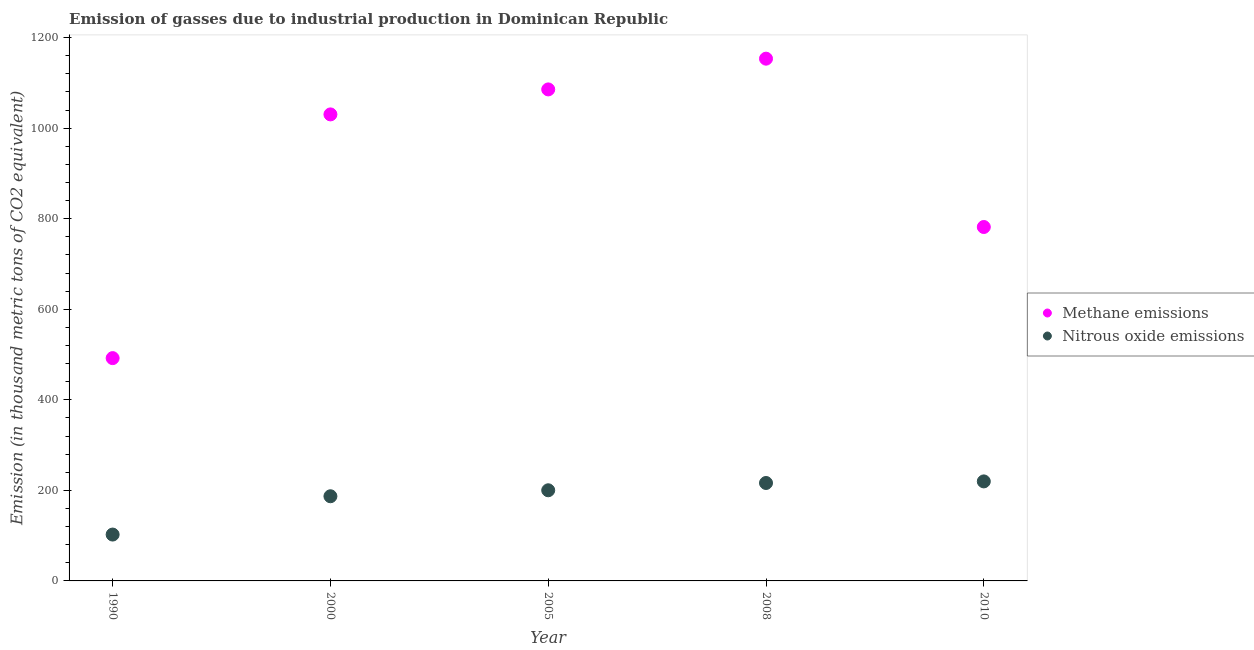Is the number of dotlines equal to the number of legend labels?
Make the answer very short. Yes. What is the amount of methane emissions in 1990?
Keep it short and to the point. 492.1. Across all years, what is the maximum amount of nitrous oxide emissions?
Make the answer very short. 219.8. Across all years, what is the minimum amount of methane emissions?
Ensure brevity in your answer.  492.1. What is the total amount of nitrous oxide emissions in the graph?
Your response must be concise. 925.7. What is the difference between the amount of nitrous oxide emissions in 1990 and that in 2005?
Your answer should be very brief. -97.8. What is the difference between the amount of methane emissions in 1990 and the amount of nitrous oxide emissions in 2008?
Offer a terse response. 275.8. What is the average amount of methane emissions per year?
Ensure brevity in your answer.  908.66. In the year 2008, what is the difference between the amount of methane emissions and amount of nitrous oxide emissions?
Provide a succinct answer. 937.2. What is the ratio of the amount of methane emissions in 2008 to that in 2010?
Your response must be concise. 1.48. Is the amount of nitrous oxide emissions in 2000 less than that in 2008?
Give a very brief answer. Yes. What is the difference between the highest and the lowest amount of methane emissions?
Keep it short and to the point. 661.4. How many dotlines are there?
Give a very brief answer. 2. How many years are there in the graph?
Offer a very short reply. 5. What is the difference between two consecutive major ticks on the Y-axis?
Provide a succinct answer. 200. Are the values on the major ticks of Y-axis written in scientific E-notation?
Provide a succinct answer. No. Does the graph contain grids?
Your answer should be very brief. No. Where does the legend appear in the graph?
Offer a terse response. Center right. How are the legend labels stacked?
Your answer should be compact. Vertical. What is the title of the graph?
Your response must be concise. Emission of gasses due to industrial production in Dominican Republic. What is the label or title of the Y-axis?
Your answer should be compact. Emission (in thousand metric tons of CO2 equivalent). What is the Emission (in thousand metric tons of CO2 equivalent) in Methane emissions in 1990?
Make the answer very short. 492.1. What is the Emission (in thousand metric tons of CO2 equivalent) in Nitrous oxide emissions in 1990?
Your answer should be compact. 102.4. What is the Emission (in thousand metric tons of CO2 equivalent) of Methane emissions in 2000?
Provide a short and direct response. 1030.4. What is the Emission (in thousand metric tons of CO2 equivalent) in Nitrous oxide emissions in 2000?
Provide a short and direct response. 187. What is the Emission (in thousand metric tons of CO2 equivalent) of Methane emissions in 2005?
Offer a terse response. 1085.6. What is the Emission (in thousand metric tons of CO2 equivalent) of Nitrous oxide emissions in 2005?
Make the answer very short. 200.2. What is the Emission (in thousand metric tons of CO2 equivalent) of Methane emissions in 2008?
Your answer should be very brief. 1153.5. What is the Emission (in thousand metric tons of CO2 equivalent) of Nitrous oxide emissions in 2008?
Offer a very short reply. 216.3. What is the Emission (in thousand metric tons of CO2 equivalent) in Methane emissions in 2010?
Give a very brief answer. 781.7. What is the Emission (in thousand metric tons of CO2 equivalent) of Nitrous oxide emissions in 2010?
Keep it short and to the point. 219.8. Across all years, what is the maximum Emission (in thousand metric tons of CO2 equivalent) of Methane emissions?
Ensure brevity in your answer.  1153.5. Across all years, what is the maximum Emission (in thousand metric tons of CO2 equivalent) of Nitrous oxide emissions?
Provide a succinct answer. 219.8. Across all years, what is the minimum Emission (in thousand metric tons of CO2 equivalent) of Methane emissions?
Offer a very short reply. 492.1. Across all years, what is the minimum Emission (in thousand metric tons of CO2 equivalent) in Nitrous oxide emissions?
Offer a very short reply. 102.4. What is the total Emission (in thousand metric tons of CO2 equivalent) in Methane emissions in the graph?
Ensure brevity in your answer.  4543.3. What is the total Emission (in thousand metric tons of CO2 equivalent) of Nitrous oxide emissions in the graph?
Ensure brevity in your answer.  925.7. What is the difference between the Emission (in thousand metric tons of CO2 equivalent) of Methane emissions in 1990 and that in 2000?
Provide a short and direct response. -538.3. What is the difference between the Emission (in thousand metric tons of CO2 equivalent) of Nitrous oxide emissions in 1990 and that in 2000?
Provide a short and direct response. -84.6. What is the difference between the Emission (in thousand metric tons of CO2 equivalent) of Methane emissions in 1990 and that in 2005?
Offer a very short reply. -593.5. What is the difference between the Emission (in thousand metric tons of CO2 equivalent) in Nitrous oxide emissions in 1990 and that in 2005?
Make the answer very short. -97.8. What is the difference between the Emission (in thousand metric tons of CO2 equivalent) of Methane emissions in 1990 and that in 2008?
Give a very brief answer. -661.4. What is the difference between the Emission (in thousand metric tons of CO2 equivalent) of Nitrous oxide emissions in 1990 and that in 2008?
Make the answer very short. -113.9. What is the difference between the Emission (in thousand metric tons of CO2 equivalent) of Methane emissions in 1990 and that in 2010?
Provide a succinct answer. -289.6. What is the difference between the Emission (in thousand metric tons of CO2 equivalent) of Nitrous oxide emissions in 1990 and that in 2010?
Provide a succinct answer. -117.4. What is the difference between the Emission (in thousand metric tons of CO2 equivalent) in Methane emissions in 2000 and that in 2005?
Provide a succinct answer. -55.2. What is the difference between the Emission (in thousand metric tons of CO2 equivalent) of Methane emissions in 2000 and that in 2008?
Provide a succinct answer. -123.1. What is the difference between the Emission (in thousand metric tons of CO2 equivalent) in Nitrous oxide emissions in 2000 and that in 2008?
Give a very brief answer. -29.3. What is the difference between the Emission (in thousand metric tons of CO2 equivalent) of Methane emissions in 2000 and that in 2010?
Your response must be concise. 248.7. What is the difference between the Emission (in thousand metric tons of CO2 equivalent) in Nitrous oxide emissions in 2000 and that in 2010?
Offer a terse response. -32.8. What is the difference between the Emission (in thousand metric tons of CO2 equivalent) of Methane emissions in 2005 and that in 2008?
Keep it short and to the point. -67.9. What is the difference between the Emission (in thousand metric tons of CO2 equivalent) in Nitrous oxide emissions in 2005 and that in 2008?
Keep it short and to the point. -16.1. What is the difference between the Emission (in thousand metric tons of CO2 equivalent) of Methane emissions in 2005 and that in 2010?
Make the answer very short. 303.9. What is the difference between the Emission (in thousand metric tons of CO2 equivalent) of Nitrous oxide emissions in 2005 and that in 2010?
Give a very brief answer. -19.6. What is the difference between the Emission (in thousand metric tons of CO2 equivalent) of Methane emissions in 2008 and that in 2010?
Offer a terse response. 371.8. What is the difference between the Emission (in thousand metric tons of CO2 equivalent) of Methane emissions in 1990 and the Emission (in thousand metric tons of CO2 equivalent) of Nitrous oxide emissions in 2000?
Offer a terse response. 305.1. What is the difference between the Emission (in thousand metric tons of CO2 equivalent) of Methane emissions in 1990 and the Emission (in thousand metric tons of CO2 equivalent) of Nitrous oxide emissions in 2005?
Make the answer very short. 291.9. What is the difference between the Emission (in thousand metric tons of CO2 equivalent) in Methane emissions in 1990 and the Emission (in thousand metric tons of CO2 equivalent) in Nitrous oxide emissions in 2008?
Offer a terse response. 275.8. What is the difference between the Emission (in thousand metric tons of CO2 equivalent) in Methane emissions in 1990 and the Emission (in thousand metric tons of CO2 equivalent) in Nitrous oxide emissions in 2010?
Provide a succinct answer. 272.3. What is the difference between the Emission (in thousand metric tons of CO2 equivalent) in Methane emissions in 2000 and the Emission (in thousand metric tons of CO2 equivalent) in Nitrous oxide emissions in 2005?
Offer a terse response. 830.2. What is the difference between the Emission (in thousand metric tons of CO2 equivalent) of Methane emissions in 2000 and the Emission (in thousand metric tons of CO2 equivalent) of Nitrous oxide emissions in 2008?
Keep it short and to the point. 814.1. What is the difference between the Emission (in thousand metric tons of CO2 equivalent) of Methane emissions in 2000 and the Emission (in thousand metric tons of CO2 equivalent) of Nitrous oxide emissions in 2010?
Provide a succinct answer. 810.6. What is the difference between the Emission (in thousand metric tons of CO2 equivalent) in Methane emissions in 2005 and the Emission (in thousand metric tons of CO2 equivalent) in Nitrous oxide emissions in 2008?
Your answer should be very brief. 869.3. What is the difference between the Emission (in thousand metric tons of CO2 equivalent) of Methane emissions in 2005 and the Emission (in thousand metric tons of CO2 equivalent) of Nitrous oxide emissions in 2010?
Offer a very short reply. 865.8. What is the difference between the Emission (in thousand metric tons of CO2 equivalent) in Methane emissions in 2008 and the Emission (in thousand metric tons of CO2 equivalent) in Nitrous oxide emissions in 2010?
Offer a terse response. 933.7. What is the average Emission (in thousand metric tons of CO2 equivalent) in Methane emissions per year?
Give a very brief answer. 908.66. What is the average Emission (in thousand metric tons of CO2 equivalent) in Nitrous oxide emissions per year?
Keep it short and to the point. 185.14. In the year 1990, what is the difference between the Emission (in thousand metric tons of CO2 equivalent) in Methane emissions and Emission (in thousand metric tons of CO2 equivalent) in Nitrous oxide emissions?
Your answer should be compact. 389.7. In the year 2000, what is the difference between the Emission (in thousand metric tons of CO2 equivalent) of Methane emissions and Emission (in thousand metric tons of CO2 equivalent) of Nitrous oxide emissions?
Ensure brevity in your answer.  843.4. In the year 2005, what is the difference between the Emission (in thousand metric tons of CO2 equivalent) in Methane emissions and Emission (in thousand metric tons of CO2 equivalent) in Nitrous oxide emissions?
Ensure brevity in your answer.  885.4. In the year 2008, what is the difference between the Emission (in thousand metric tons of CO2 equivalent) in Methane emissions and Emission (in thousand metric tons of CO2 equivalent) in Nitrous oxide emissions?
Make the answer very short. 937.2. In the year 2010, what is the difference between the Emission (in thousand metric tons of CO2 equivalent) of Methane emissions and Emission (in thousand metric tons of CO2 equivalent) of Nitrous oxide emissions?
Your response must be concise. 561.9. What is the ratio of the Emission (in thousand metric tons of CO2 equivalent) of Methane emissions in 1990 to that in 2000?
Provide a succinct answer. 0.48. What is the ratio of the Emission (in thousand metric tons of CO2 equivalent) of Nitrous oxide emissions in 1990 to that in 2000?
Give a very brief answer. 0.55. What is the ratio of the Emission (in thousand metric tons of CO2 equivalent) of Methane emissions in 1990 to that in 2005?
Your answer should be compact. 0.45. What is the ratio of the Emission (in thousand metric tons of CO2 equivalent) in Nitrous oxide emissions in 1990 to that in 2005?
Offer a very short reply. 0.51. What is the ratio of the Emission (in thousand metric tons of CO2 equivalent) in Methane emissions in 1990 to that in 2008?
Provide a short and direct response. 0.43. What is the ratio of the Emission (in thousand metric tons of CO2 equivalent) of Nitrous oxide emissions in 1990 to that in 2008?
Your answer should be compact. 0.47. What is the ratio of the Emission (in thousand metric tons of CO2 equivalent) of Methane emissions in 1990 to that in 2010?
Provide a short and direct response. 0.63. What is the ratio of the Emission (in thousand metric tons of CO2 equivalent) in Nitrous oxide emissions in 1990 to that in 2010?
Your answer should be compact. 0.47. What is the ratio of the Emission (in thousand metric tons of CO2 equivalent) of Methane emissions in 2000 to that in 2005?
Provide a short and direct response. 0.95. What is the ratio of the Emission (in thousand metric tons of CO2 equivalent) in Nitrous oxide emissions in 2000 to that in 2005?
Your answer should be compact. 0.93. What is the ratio of the Emission (in thousand metric tons of CO2 equivalent) in Methane emissions in 2000 to that in 2008?
Give a very brief answer. 0.89. What is the ratio of the Emission (in thousand metric tons of CO2 equivalent) in Nitrous oxide emissions in 2000 to that in 2008?
Ensure brevity in your answer.  0.86. What is the ratio of the Emission (in thousand metric tons of CO2 equivalent) of Methane emissions in 2000 to that in 2010?
Your response must be concise. 1.32. What is the ratio of the Emission (in thousand metric tons of CO2 equivalent) in Nitrous oxide emissions in 2000 to that in 2010?
Ensure brevity in your answer.  0.85. What is the ratio of the Emission (in thousand metric tons of CO2 equivalent) in Methane emissions in 2005 to that in 2008?
Give a very brief answer. 0.94. What is the ratio of the Emission (in thousand metric tons of CO2 equivalent) of Nitrous oxide emissions in 2005 to that in 2008?
Keep it short and to the point. 0.93. What is the ratio of the Emission (in thousand metric tons of CO2 equivalent) of Methane emissions in 2005 to that in 2010?
Your answer should be compact. 1.39. What is the ratio of the Emission (in thousand metric tons of CO2 equivalent) of Nitrous oxide emissions in 2005 to that in 2010?
Provide a short and direct response. 0.91. What is the ratio of the Emission (in thousand metric tons of CO2 equivalent) of Methane emissions in 2008 to that in 2010?
Provide a succinct answer. 1.48. What is the ratio of the Emission (in thousand metric tons of CO2 equivalent) of Nitrous oxide emissions in 2008 to that in 2010?
Your answer should be very brief. 0.98. What is the difference between the highest and the second highest Emission (in thousand metric tons of CO2 equivalent) of Methane emissions?
Give a very brief answer. 67.9. What is the difference between the highest and the lowest Emission (in thousand metric tons of CO2 equivalent) in Methane emissions?
Your answer should be very brief. 661.4. What is the difference between the highest and the lowest Emission (in thousand metric tons of CO2 equivalent) in Nitrous oxide emissions?
Make the answer very short. 117.4. 